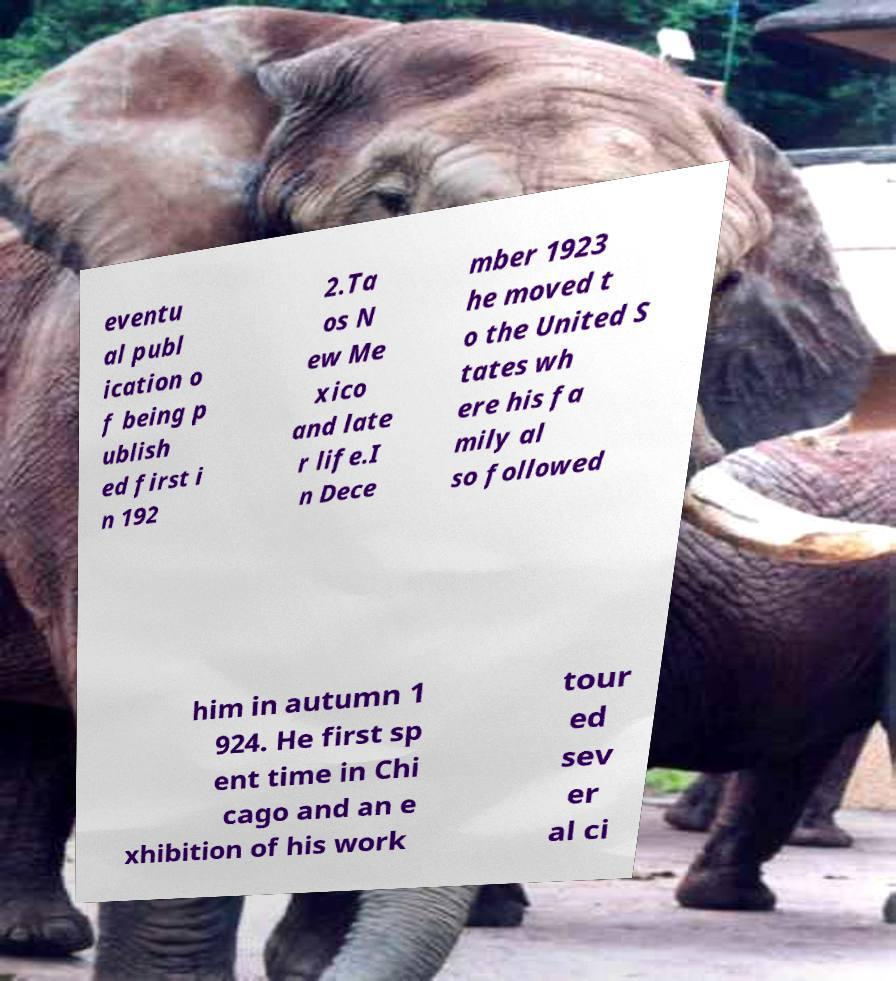I need the written content from this picture converted into text. Can you do that? eventu al publ ication o f being p ublish ed first i n 192 2.Ta os N ew Me xico and late r life.I n Dece mber 1923 he moved t o the United S tates wh ere his fa mily al so followed him in autumn 1 924. He first sp ent time in Chi cago and an e xhibition of his work tour ed sev er al ci 